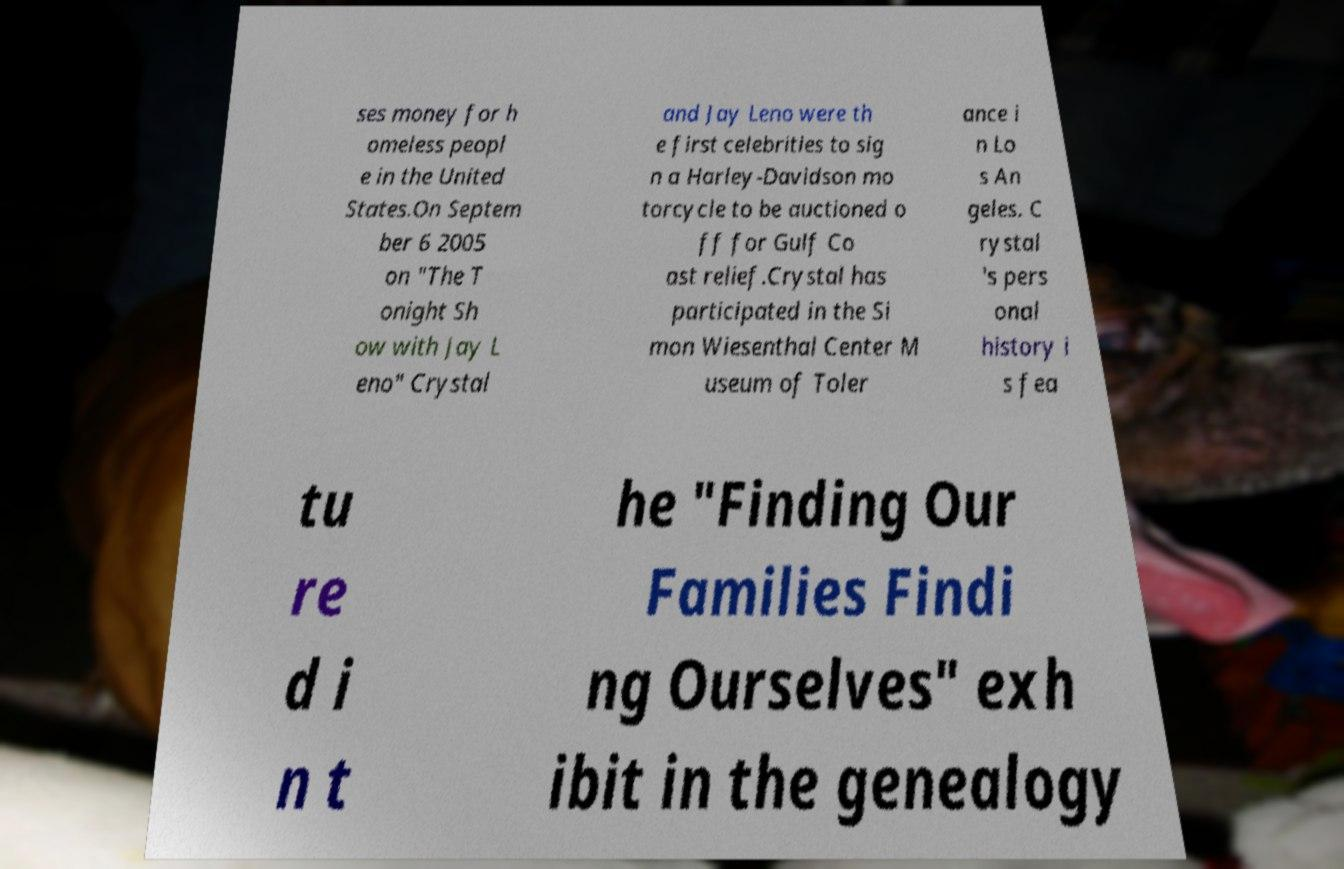I need the written content from this picture converted into text. Can you do that? ses money for h omeless peopl e in the United States.On Septem ber 6 2005 on "The T onight Sh ow with Jay L eno" Crystal and Jay Leno were th e first celebrities to sig n a Harley-Davidson mo torcycle to be auctioned o ff for Gulf Co ast relief.Crystal has participated in the Si mon Wiesenthal Center M useum of Toler ance i n Lo s An geles. C rystal 's pers onal history i s fea tu re d i n t he "Finding Our Families Findi ng Ourselves" exh ibit in the genealogy 